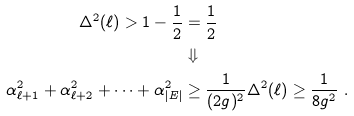Convert formula to latex. <formula><loc_0><loc_0><loc_500><loc_500>\Delta ^ { 2 } ( \ell ) > 1 - \frac { 1 } { 2 } & = \frac { 1 } { 2 } \\ & \Downarrow \\ \alpha _ { \ell + 1 } ^ { 2 } + \alpha _ { \ell + 2 } ^ { 2 } + \dots + \alpha _ { | E | } ^ { 2 } & \geq \frac { 1 } { ( 2 g ) ^ { 2 } } \Delta ^ { 2 } ( \ell ) \geq \frac { 1 } { 8 g ^ { 2 } } \ .</formula> 